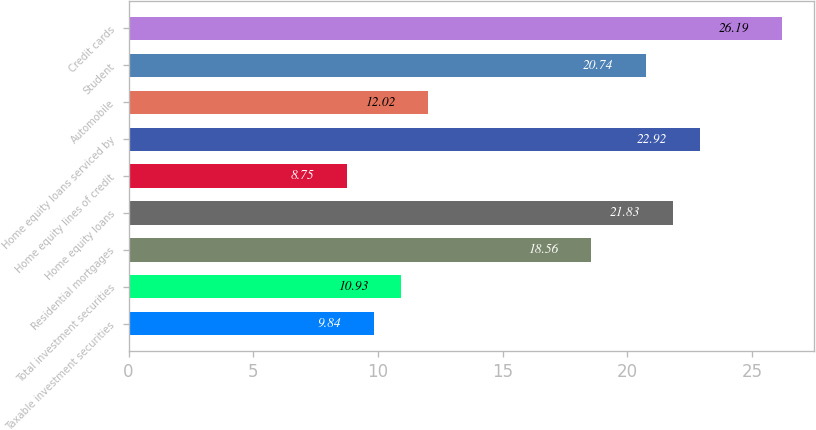Convert chart to OTSL. <chart><loc_0><loc_0><loc_500><loc_500><bar_chart><fcel>Taxable investment securities<fcel>Total investment securities<fcel>Residential mortgages<fcel>Home equity loans<fcel>Home equity lines of credit<fcel>Home equity loans serviced by<fcel>Automobile<fcel>Student<fcel>Credit cards<nl><fcel>9.84<fcel>10.93<fcel>18.56<fcel>21.83<fcel>8.75<fcel>22.92<fcel>12.02<fcel>20.74<fcel>26.19<nl></chart> 